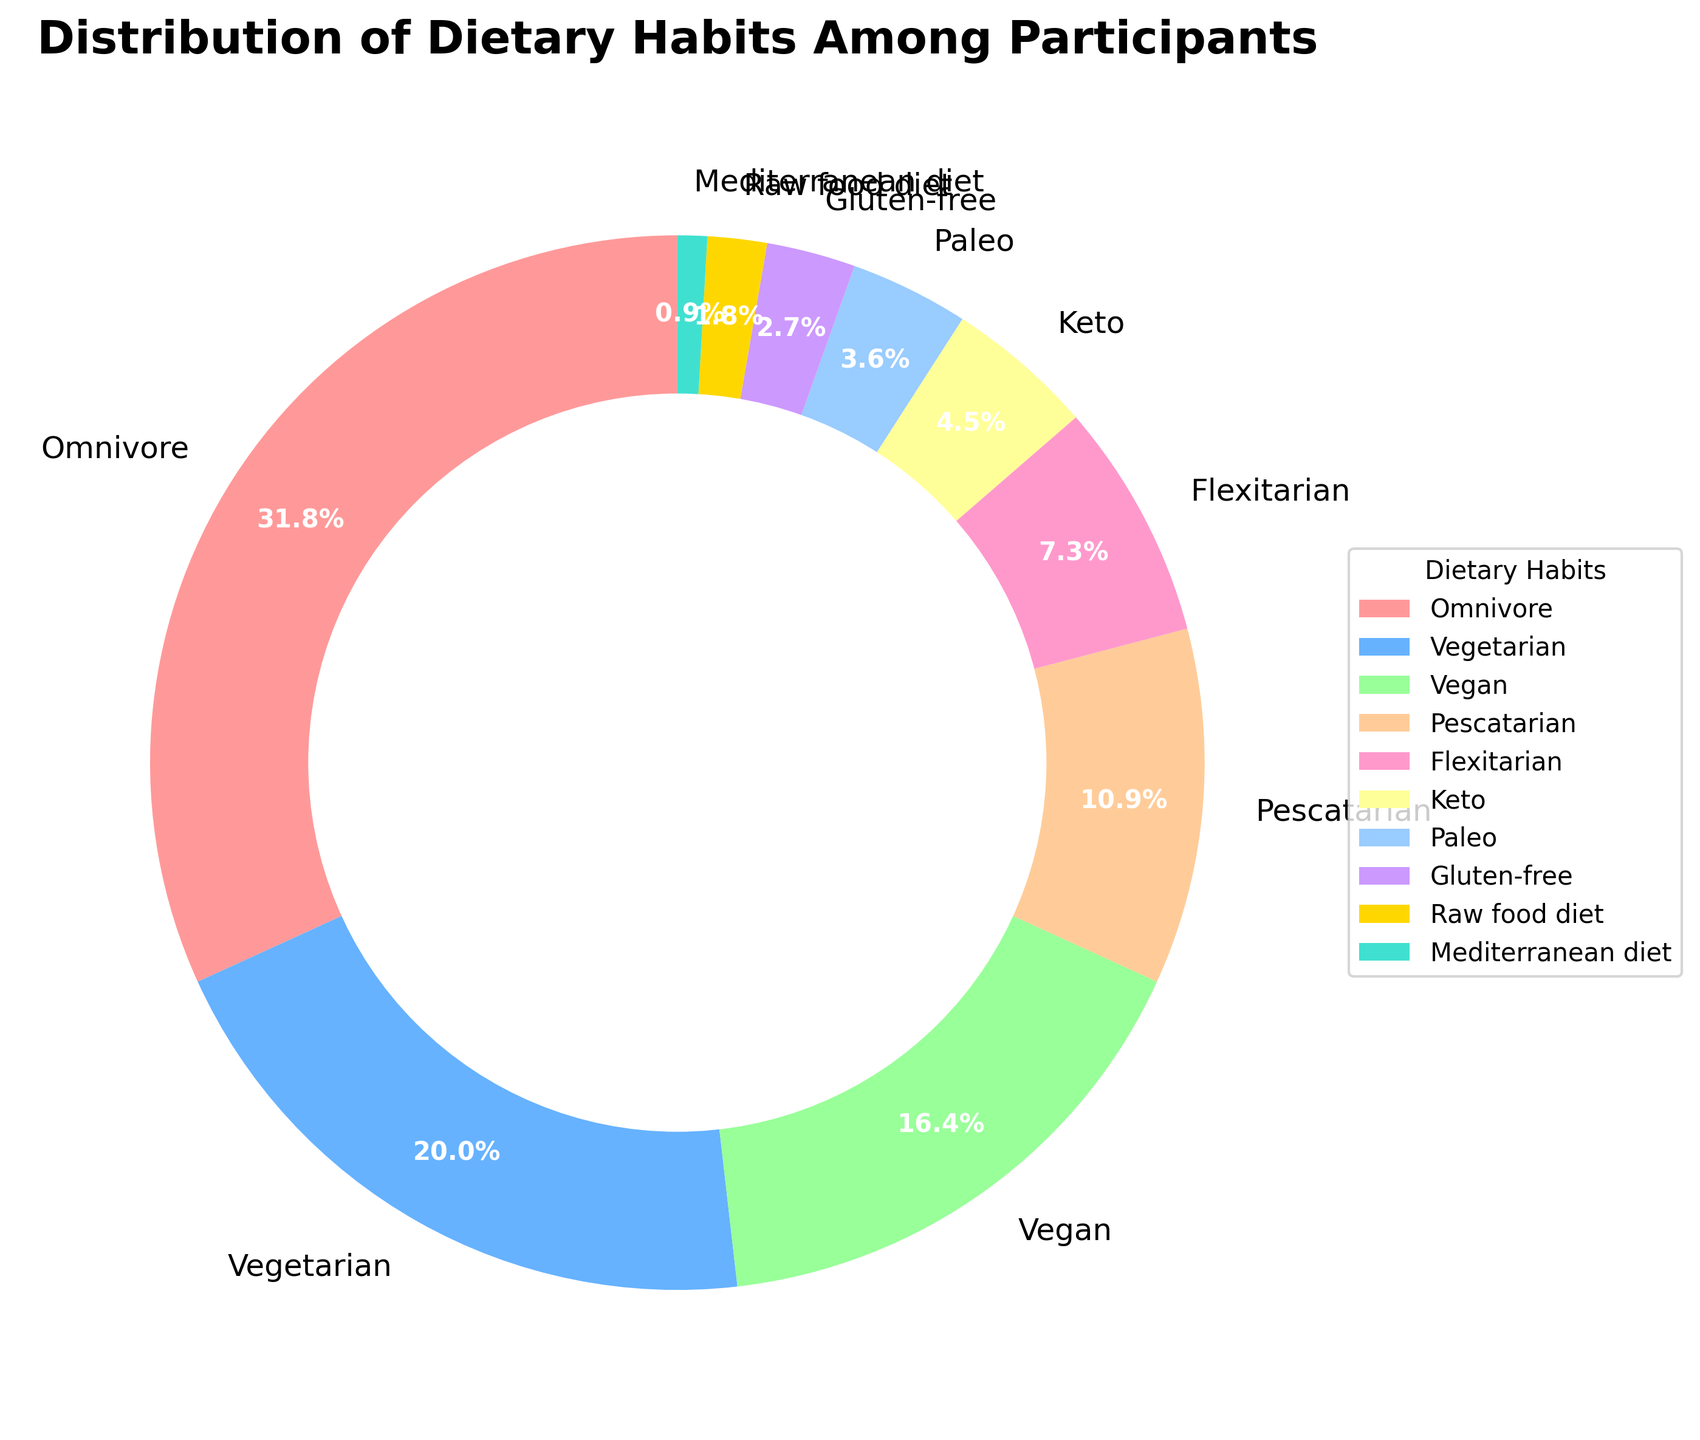what percentage of participants follow a vegetarian diet? Identify the slice labeled "Vegetarian" in the pie chart. The percentage value should be displayed beside the label within the slice.
Answer: 22% Which dietary habit has the lowest percentage of participants, and what is that percentage? Find the smallest slice in the pie chart and read the label and percentage value associated with it.
Answer: Mediterranean diet, 1% What is the combined percentage of participants who follow vegan and pescatarian diets? Locate the slices marked "Vegan" and "Pescatarian". Add their percentages together: 18% (Vegan) + 12% (Pescatarian).
Answer: 30% Which dietary habit is followed by more participants: Keto or Paleo? Compare the slices labeled "Keto" and "Paleo" to see which one has a higher percentage.
Answer: Keto How much larger is the percentage of omnivores compared to flexitarians? Locate the slices for "Omnivore" and "Flexitarian". Subtract the percentage of flexitarians from the percentage of omnivores: 35% (Omnivore) - 8% (Flexitarian).
Answer: 27% What dietary habit is represented by the green slice, and what is its percentage? Identify the slice colored in green, then read its label and percentage.
Answer: Vegan, 18% How do the percentages of vegetarians and keto dieters compare? Compare the slices labeled "Vegetarian" (22%) and "Keto" (5%) to see which one is larger and by how much. 22% (Vegetarian) - 5% (Keto).
Answer: Vegetarian by 17% What is the total percentage of participants following the top three dietary habits? Identify the top three largest slices: Omnivore, Vegetarian, and Vegan. Add their percentages: 35% (Omnivore) + 22% (Vegetarian) + 18% (Vegan).
Answer: 75% Which dietary habit is represented by the red slice, and what is its percentage? Identify the slice colored in red, then read its label and percentage.
Answer: Omnivore, 35% How many dietary habits have a percentage of 5% or lower among the participants? Count the slices that have a percentage value of 5% or lower: Keto (5%), Paleo (4%), Gluten-free (3%), Raw food diet (2%), Mediterranean diet (1%).
Answer: 5 